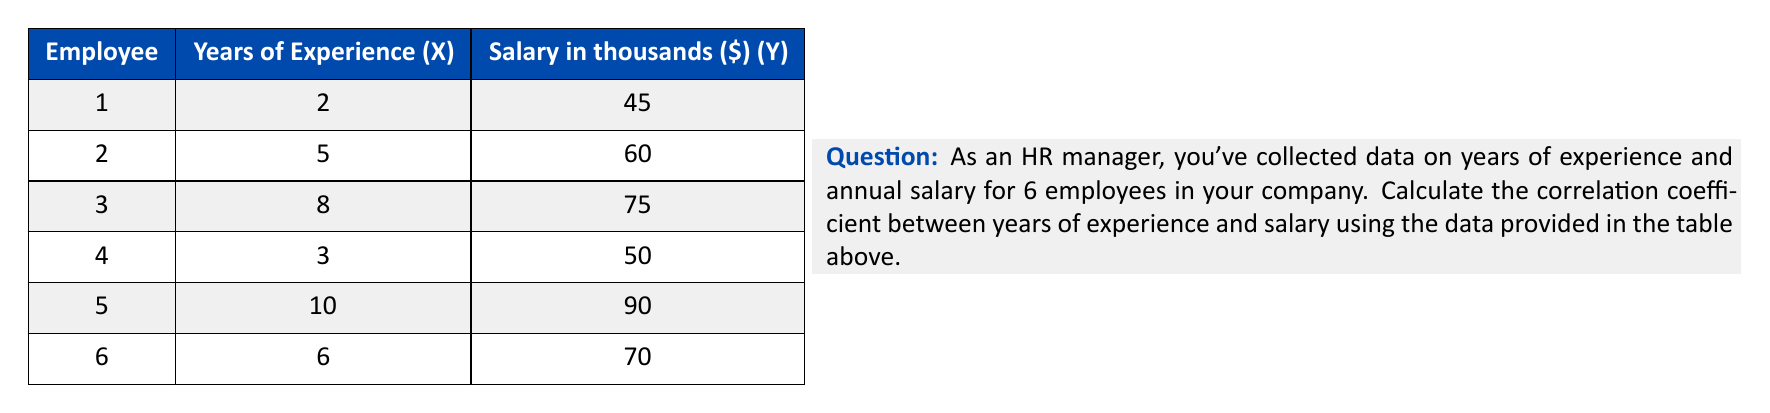Give your solution to this math problem. To calculate the correlation coefficient (r), we'll use the formula:

$$ r = \frac{n\sum xy - \sum x \sum y}{\sqrt{[n\sum x^2 - (\sum x)^2][n\sum y^2 - (\sum y)^2]}} $$

Step 1: Calculate the sums and squared sums:
$\sum x = 34$, $\sum y = 390$, $\sum x^2 = 274$, $\sum y^2 = 26,150$, $\sum xy = 2,370$

Step 2: Calculate $n\sum xy$:
$n\sum xy = 6 \times 2,370 = 14,220$

Step 3: Calculate $\sum x \sum y$:
$\sum x \sum y = 34 \times 390 = 13,260$

Step 4: Calculate the numerator:
$n\sum xy - \sum x \sum y = 14,220 - 13,260 = 960$

Step 5: Calculate the denominator parts:
$n\sum x^2 - (\sum x)^2 = 6 \times 274 - 34^2 = 1,644 - 1,156 = 488$
$n\sum y^2 - (\sum y)^2 = 6 \times 26,150 - 390^2 = 156,900 - 152,100 = 4,800$

Step 6: Calculate the denominator:
$\sqrt{488 \times 4,800} = \sqrt{2,342,400} = 1,530.49$

Step 7: Calculate the correlation coefficient:
$r = \frac{960}{1,530.49} = 0.6273$
Answer: $r \approx 0.63$ 